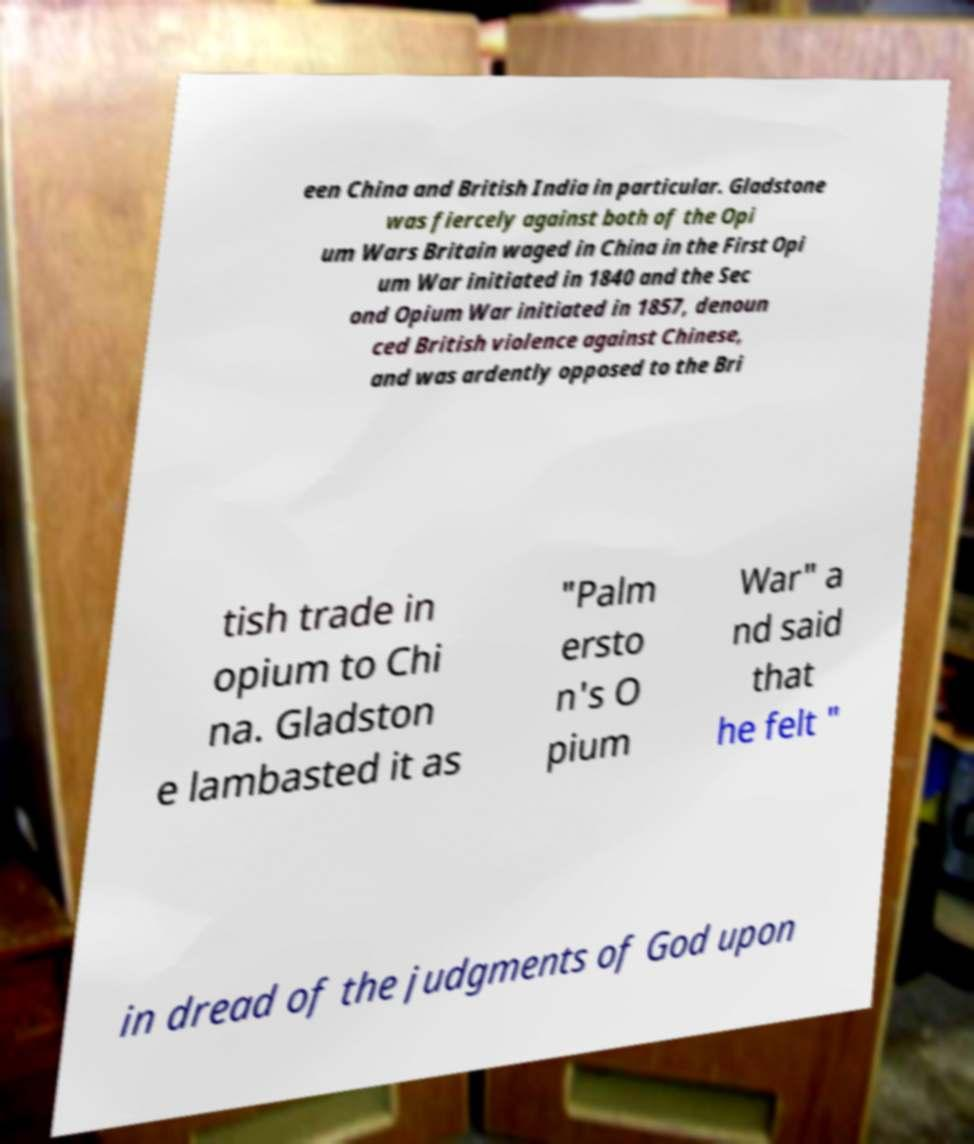I need the written content from this picture converted into text. Can you do that? een China and British India in particular. Gladstone was fiercely against both of the Opi um Wars Britain waged in China in the First Opi um War initiated in 1840 and the Sec ond Opium War initiated in 1857, denoun ced British violence against Chinese, and was ardently opposed to the Bri tish trade in opium to Chi na. Gladston e lambasted it as "Palm ersto n's O pium War" a nd said that he felt " in dread of the judgments of God upon 